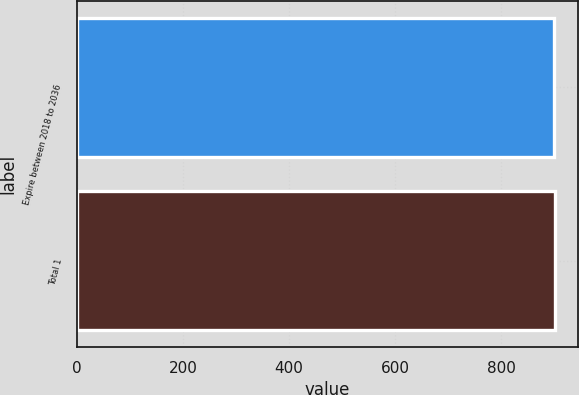Convert chart. <chart><loc_0><loc_0><loc_500><loc_500><bar_chart><fcel>Expire between 2018 to 2036<fcel>Total 1<nl><fcel>901<fcel>901.1<nl></chart> 